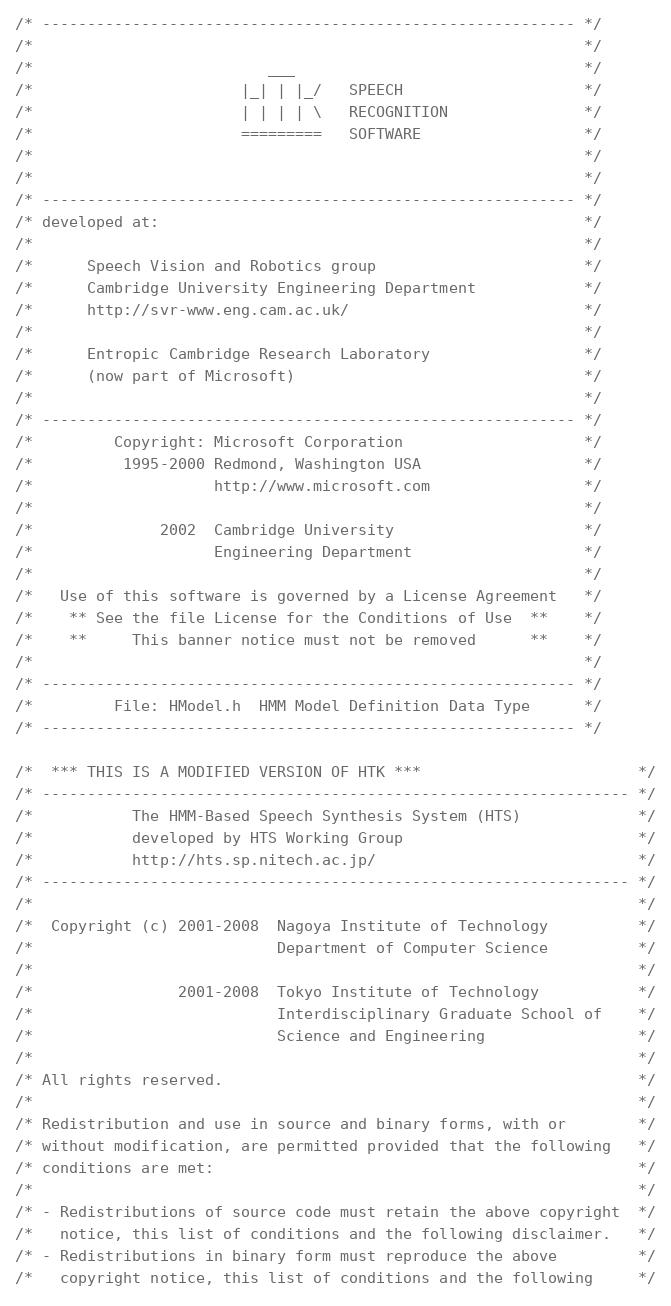Convert code to text. <code><loc_0><loc_0><loc_500><loc_500><_C_>/* ----------------------------------------------------------- */
/*                                                             */
/*                          ___                                */
/*                       |_| | |_/   SPEECH                    */
/*                       | | | | \   RECOGNITION               */
/*                       =========   SOFTWARE                  */ 
/*                                                             */
/*                                                             */
/* ----------------------------------------------------------- */
/* developed at:                                               */
/*                                                             */
/*      Speech Vision and Robotics group                       */
/*      Cambridge University Engineering Department            */
/*      http://svr-www.eng.cam.ac.uk/                          */
/*                                                             */
/*      Entropic Cambridge Research Laboratory                 */
/*      (now part of Microsoft)                                */
/*                                                             */
/* ----------------------------------------------------------- */
/*         Copyright: Microsoft Corporation                    */
/*          1995-2000 Redmond, Washington USA                  */
/*                    http://www.microsoft.com                 */
/*                                                             */
/*              2002  Cambridge University                     */
/*                    Engineering Department                   */
/*                                                             */
/*   Use of this software is governed by a License Agreement   */
/*    ** See the file License for the Conditions of Use  **    */
/*    **     This banner notice must not be removed      **    */
/*                                                             */
/* ----------------------------------------------------------- */
/*         File: HModel.h  HMM Model Definition Data Type      */
/* ----------------------------------------------------------- */

/*  *** THIS IS A MODIFIED VERSION OF HTK ***                        */
/* ----------------------------------------------------------------- */
/*           The HMM-Based Speech Synthesis System (HTS)             */
/*           developed by HTS Working Group                          */
/*           http://hts.sp.nitech.ac.jp/                             */
/* ----------------------------------------------------------------- */
/*                                                                   */
/*  Copyright (c) 2001-2008  Nagoya Institute of Technology          */
/*                           Department of Computer Science          */
/*                                                                   */
/*                2001-2008  Tokyo Institute of Technology           */
/*                           Interdisciplinary Graduate School of    */
/*                           Science and Engineering                 */
/*                                                                   */
/* All rights reserved.                                              */
/*                                                                   */
/* Redistribution and use in source and binary forms, with or        */
/* without modification, are permitted provided that the following   */
/* conditions are met:                                               */
/*                                                                   */
/* - Redistributions of source code must retain the above copyright  */
/*   notice, this list of conditions and the following disclaimer.   */
/* - Redistributions in binary form must reproduce the above         */
/*   copyright notice, this list of conditions and the following     */</code> 